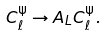Convert formula to latex. <formula><loc_0><loc_0><loc_500><loc_500>C _ { \ell } ^ { \Psi } \rightarrow A _ { L } C _ { \ell } ^ { \Psi } .</formula> 